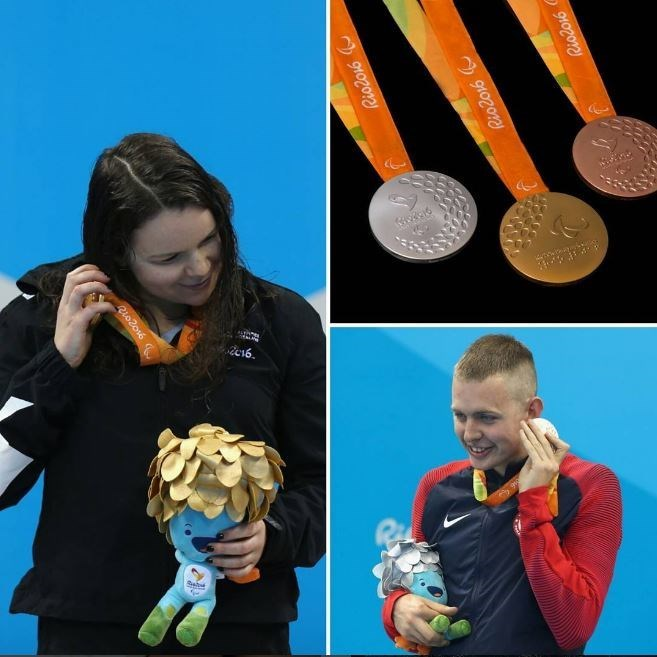Describe the emotions of the athletes as portrayed in the image. In the image, both athletes display emotions of pride and joy. The female athlete appears to be looking fondly at her silver medal, a gesture that signifies her appreciation and pride in her achievement. Similarly, the male athlete looks elated and is smiling while holding his silver medal. These expressions showcase the sentiment of accomplishment and happiness experienced by the athletes upon winning their medals. 